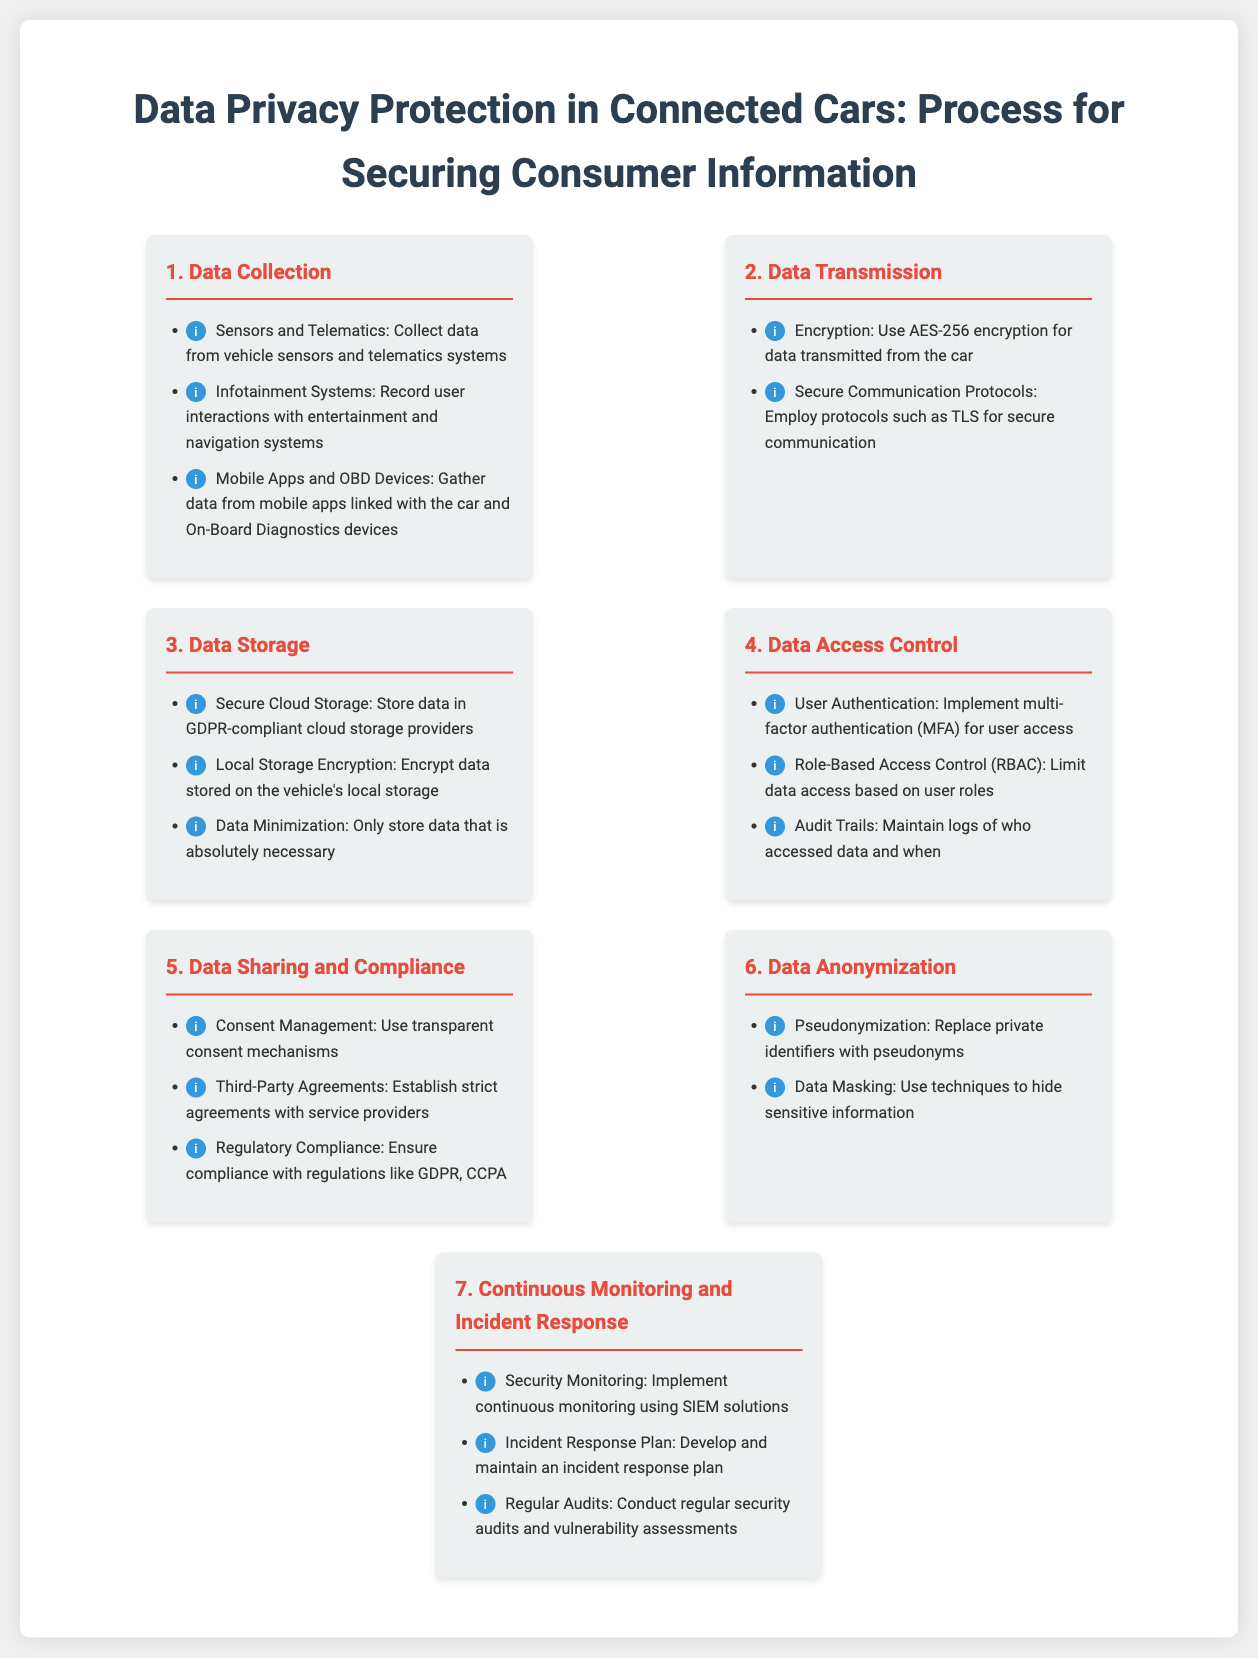What is the first step in the data privacy process? The first step in the data privacy process as defined in the infographic is 'Data Collection'.
Answer: Data Collection What encryption method is used for data transmission? The infographic specifies that AES-256 encryption is utilized for data transmitted from the car.
Answer: AES-256 What type of storage is mentioned for data storage? The infographic notes that data is stored in 'Secure Cloud Storage'.
Answer: Secure Cloud Storage What authentication method is recommended for data access control? The recommended method for user access is 'multi-factor authentication (MFA)'.
Answer: multi-factor authentication (MFA) Which regulation is emphasized for compliance in data sharing? The infographic lists the GDPR as a key regulation for compliance in data sharing and handling.
Answer: GDPR What technique is used in data anonymization? The technique mentioned for data anonymization includes 'pseudonymization'.
Answer: pseudonymization How many steps are outlined in the data privacy protection process? The infographic outlines a total of '7' steps in the data privacy protection process.
Answer: 7 What is the purpose of incident response in continuous monitoring? The purpose of the incident response plan is to 'develop and maintain an incident response plan' for security effectiveness.
Answer: develop and maintain an incident response plan What is the focus of the final step in the information process? The final step of the process is focused on 'Continuous Monitoring and Incident Response'.
Answer: Continuous Monitoring and Incident Response 